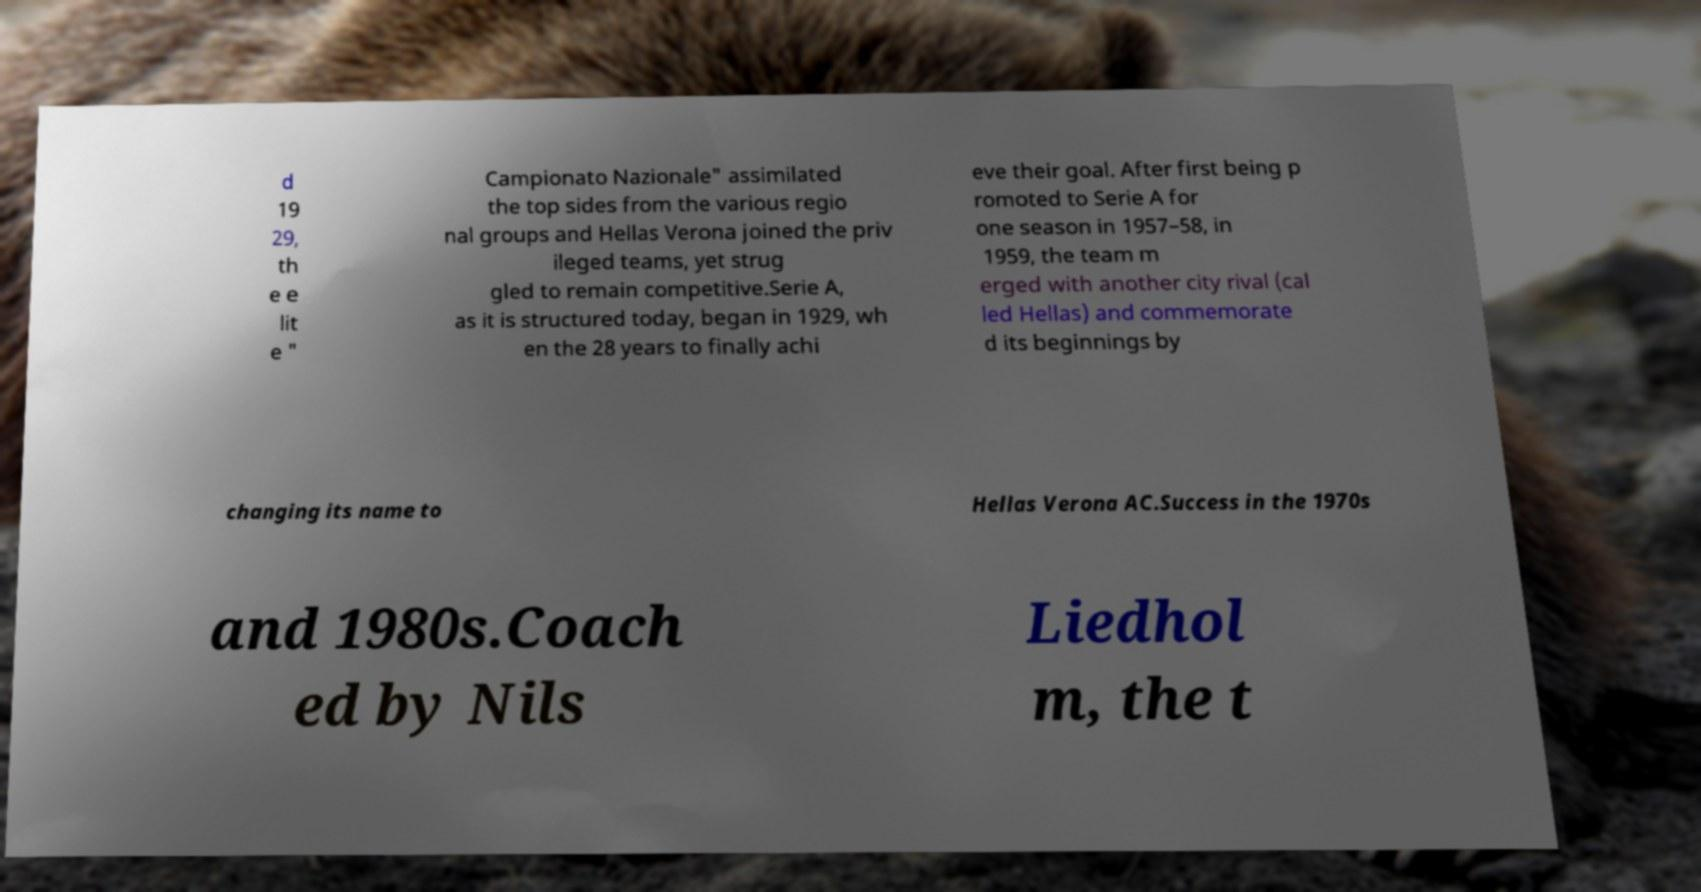Can you read and provide the text displayed in the image?This photo seems to have some interesting text. Can you extract and type it out for me? d 19 29, th e e lit e " Campionato Nazionale" assimilated the top sides from the various regio nal groups and Hellas Verona joined the priv ileged teams, yet strug gled to remain competitive.Serie A, as it is structured today, began in 1929, wh en the 28 years to finally achi eve their goal. After first being p romoted to Serie A for one season in 1957–58, in 1959, the team m erged with another city rival (cal led Hellas) and commemorate d its beginnings by changing its name to Hellas Verona AC.Success in the 1970s and 1980s.Coach ed by Nils Liedhol m, the t 